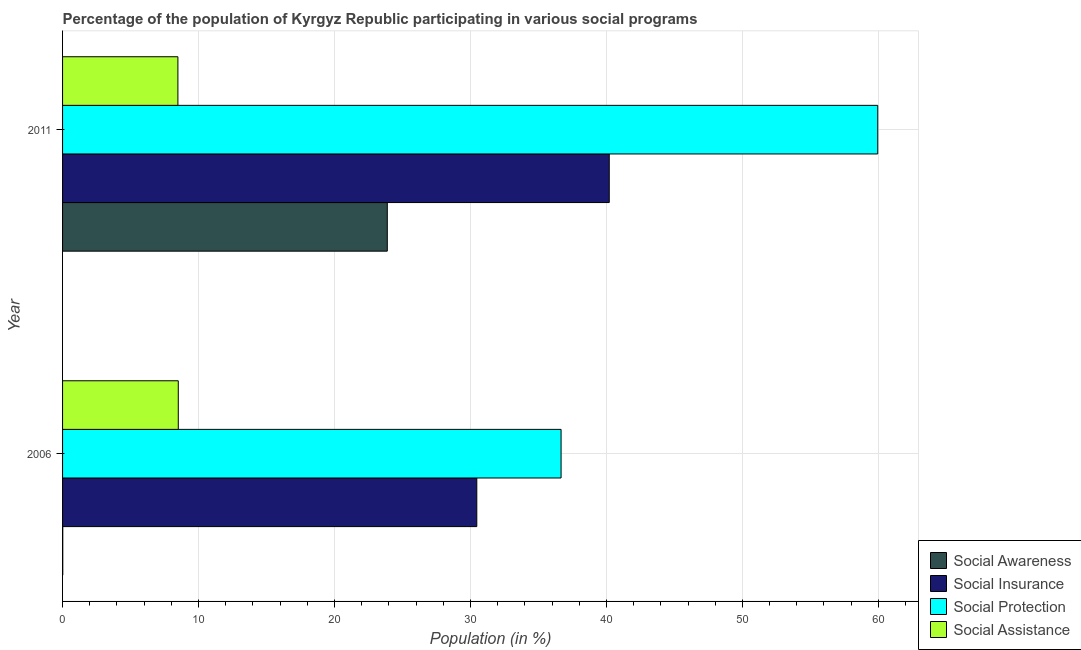What is the label of the 2nd group of bars from the top?
Offer a very short reply. 2006. What is the participation of population in social awareness programs in 2006?
Your answer should be very brief. 0.02. Across all years, what is the maximum participation of population in social awareness programs?
Your answer should be very brief. 23.88. Across all years, what is the minimum participation of population in social assistance programs?
Provide a short and direct response. 8.48. In which year was the participation of population in social awareness programs minimum?
Offer a very short reply. 2006. What is the total participation of population in social awareness programs in the graph?
Keep it short and to the point. 23.9. What is the difference between the participation of population in social assistance programs in 2006 and that in 2011?
Your answer should be compact. 0.03. What is the difference between the participation of population in social awareness programs in 2006 and the participation of population in social assistance programs in 2011?
Give a very brief answer. -8.47. What is the average participation of population in social assistance programs per year?
Your response must be concise. 8.5. In the year 2011, what is the difference between the participation of population in social insurance programs and participation of population in social protection programs?
Your answer should be compact. -19.75. What is the ratio of the participation of population in social insurance programs in 2006 to that in 2011?
Offer a terse response. 0.76. Is the difference between the participation of population in social protection programs in 2006 and 2011 greater than the difference between the participation of population in social assistance programs in 2006 and 2011?
Ensure brevity in your answer.  No. What does the 4th bar from the top in 2006 represents?
Keep it short and to the point. Social Awareness. What does the 4th bar from the bottom in 2006 represents?
Ensure brevity in your answer.  Social Assistance. How many bars are there?
Ensure brevity in your answer.  8. How many years are there in the graph?
Give a very brief answer. 2. Does the graph contain any zero values?
Make the answer very short. No. What is the title of the graph?
Ensure brevity in your answer.  Percentage of the population of Kyrgyz Republic participating in various social programs . What is the Population (in %) of Social Awareness in 2006?
Offer a very short reply. 0.02. What is the Population (in %) of Social Insurance in 2006?
Offer a terse response. 30.47. What is the Population (in %) in Social Protection in 2006?
Give a very brief answer. 36.66. What is the Population (in %) in Social Assistance in 2006?
Your response must be concise. 8.51. What is the Population (in %) of Social Awareness in 2011?
Offer a very short reply. 23.88. What is the Population (in %) in Social Insurance in 2011?
Your response must be concise. 40.21. What is the Population (in %) in Social Protection in 2011?
Your answer should be very brief. 59.95. What is the Population (in %) in Social Assistance in 2011?
Provide a succinct answer. 8.48. Across all years, what is the maximum Population (in %) in Social Awareness?
Give a very brief answer. 23.88. Across all years, what is the maximum Population (in %) in Social Insurance?
Provide a succinct answer. 40.21. Across all years, what is the maximum Population (in %) in Social Protection?
Ensure brevity in your answer.  59.95. Across all years, what is the maximum Population (in %) of Social Assistance?
Your answer should be very brief. 8.51. Across all years, what is the minimum Population (in %) of Social Awareness?
Provide a short and direct response. 0.02. Across all years, what is the minimum Population (in %) in Social Insurance?
Offer a very short reply. 30.47. Across all years, what is the minimum Population (in %) of Social Protection?
Your response must be concise. 36.66. Across all years, what is the minimum Population (in %) of Social Assistance?
Your answer should be very brief. 8.48. What is the total Population (in %) in Social Awareness in the graph?
Provide a succinct answer. 23.9. What is the total Population (in %) in Social Insurance in the graph?
Ensure brevity in your answer.  70.67. What is the total Population (in %) of Social Protection in the graph?
Your response must be concise. 96.62. What is the total Population (in %) in Social Assistance in the graph?
Ensure brevity in your answer.  16.99. What is the difference between the Population (in %) in Social Awareness in 2006 and that in 2011?
Your answer should be very brief. -23.87. What is the difference between the Population (in %) of Social Insurance in 2006 and that in 2011?
Your response must be concise. -9.74. What is the difference between the Population (in %) of Social Protection in 2006 and that in 2011?
Keep it short and to the point. -23.29. What is the difference between the Population (in %) of Social Assistance in 2006 and that in 2011?
Your answer should be compact. 0.03. What is the difference between the Population (in %) in Social Awareness in 2006 and the Population (in %) in Social Insurance in 2011?
Give a very brief answer. -40.19. What is the difference between the Population (in %) in Social Awareness in 2006 and the Population (in %) in Social Protection in 2011?
Give a very brief answer. -59.94. What is the difference between the Population (in %) of Social Awareness in 2006 and the Population (in %) of Social Assistance in 2011?
Make the answer very short. -8.47. What is the difference between the Population (in %) of Social Insurance in 2006 and the Population (in %) of Social Protection in 2011?
Your answer should be compact. -29.49. What is the difference between the Population (in %) of Social Insurance in 2006 and the Population (in %) of Social Assistance in 2011?
Offer a terse response. 21.98. What is the difference between the Population (in %) of Social Protection in 2006 and the Population (in %) of Social Assistance in 2011?
Give a very brief answer. 28.18. What is the average Population (in %) of Social Awareness per year?
Provide a succinct answer. 11.95. What is the average Population (in %) of Social Insurance per year?
Make the answer very short. 35.34. What is the average Population (in %) of Social Protection per year?
Provide a succinct answer. 48.31. What is the average Population (in %) of Social Assistance per year?
Provide a short and direct response. 8.5. In the year 2006, what is the difference between the Population (in %) of Social Awareness and Population (in %) of Social Insurance?
Your answer should be compact. -30.45. In the year 2006, what is the difference between the Population (in %) of Social Awareness and Population (in %) of Social Protection?
Offer a very short reply. -36.65. In the year 2006, what is the difference between the Population (in %) of Social Awareness and Population (in %) of Social Assistance?
Offer a very short reply. -8.5. In the year 2006, what is the difference between the Population (in %) in Social Insurance and Population (in %) in Social Protection?
Your answer should be compact. -6.2. In the year 2006, what is the difference between the Population (in %) of Social Insurance and Population (in %) of Social Assistance?
Make the answer very short. 21.96. In the year 2006, what is the difference between the Population (in %) of Social Protection and Population (in %) of Social Assistance?
Offer a very short reply. 28.15. In the year 2011, what is the difference between the Population (in %) in Social Awareness and Population (in %) in Social Insurance?
Offer a terse response. -16.33. In the year 2011, what is the difference between the Population (in %) in Social Awareness and Population (in %) in Social Protection?
Offer a terse response. -36.07. In the year 2011, what is the difference between the Population (in %) in Social Awareness and Population (in %) in Social Assistance?
Offer a terse response. 15.4. In the year 2011, what is the difference between the Population (in %) of Social Insurance and Population (in %) of Social Protection?
Ensure brevity in your answer.  -19.75. In the year 2011, what is the difference between the Population (in %) in Social Insurance and Population (in %) in Social Assistance?
Ensure brevity in your answer.  31.73. In the year 2011, what is the difference between the Population (in %) of Social Protection and Population (in %) of Social Assistance?
Make the answer very short. 51.47. What is the ratio of the Population (in %) of Social Awareness in 2006 to that in 2011?
Give a very brief answer. 0. What is the ratio of the Population (in %) of Social Insurance in 2006 to that in 2011?
Keep it short and to the point. 0.76. What is the ratio of the Population (in %) in Social Protection in 2006 to that in 2011?
Provide a succinct answer. 0.61. What is the ratio of the Population (in %) of Social Assistance in 2006 to that in 2011?
Make the answer very short. 1. What is the difference between the highest and the second highest Population (in %) in Social Awareness?
Your answer should be very brief. 23.87. What is the difference between the highest and the second highest Population (in %) of Social Insurance?
Provide a short and direct response. 9.74. What is the difference between the highest and the second highest Population (in %) of Social Protection?
Keep it short and to the point. 23.29. What is the difference between the highest and the second highest Population (in %) in Social Assistance?
Your answer should be very brief. 0.03. What is the difference between the highest and the lowest Population (in %) of Social Awareness?
Your response must be concise. 23.87. What is the difference between the highest and the lowest Population (in %) of Social Insurance?
Ensure brevity in your answer.  9.74. What is the difference between the highest and the lowest Population (in %) in Social Protection?
Offer a terse response. 23.29. What is the difference between the highest and the lowest Population (in %) of Social Assistance?
Offer a very short reply. 0.03. 